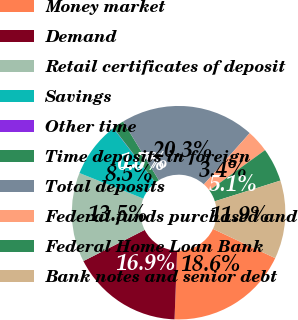Convert chart to OTSL. <chart><loc_0><loc_0><loc_500><loc_500><pie_chart><fcel>Money market<fcel>Demand<fcel>Retail certificates of deposit<fcel>Savings<fcel>Other time<fcel>Time deposits in foreign<fcel>Total deposits<fcel>Federal funds purchased and<fcel>Federal Home Loan Bank<fcel>Bank notes and senior debt<nl><fcel>18.61%<fcel>16.92%<fcel>13.54%<fcel>8.48%<fcel>0.04%<fcel>1.73%<fcel>20.3%<fcel>3.42%<fcel>5.11%<fcel>11.86%<nl></chart> 